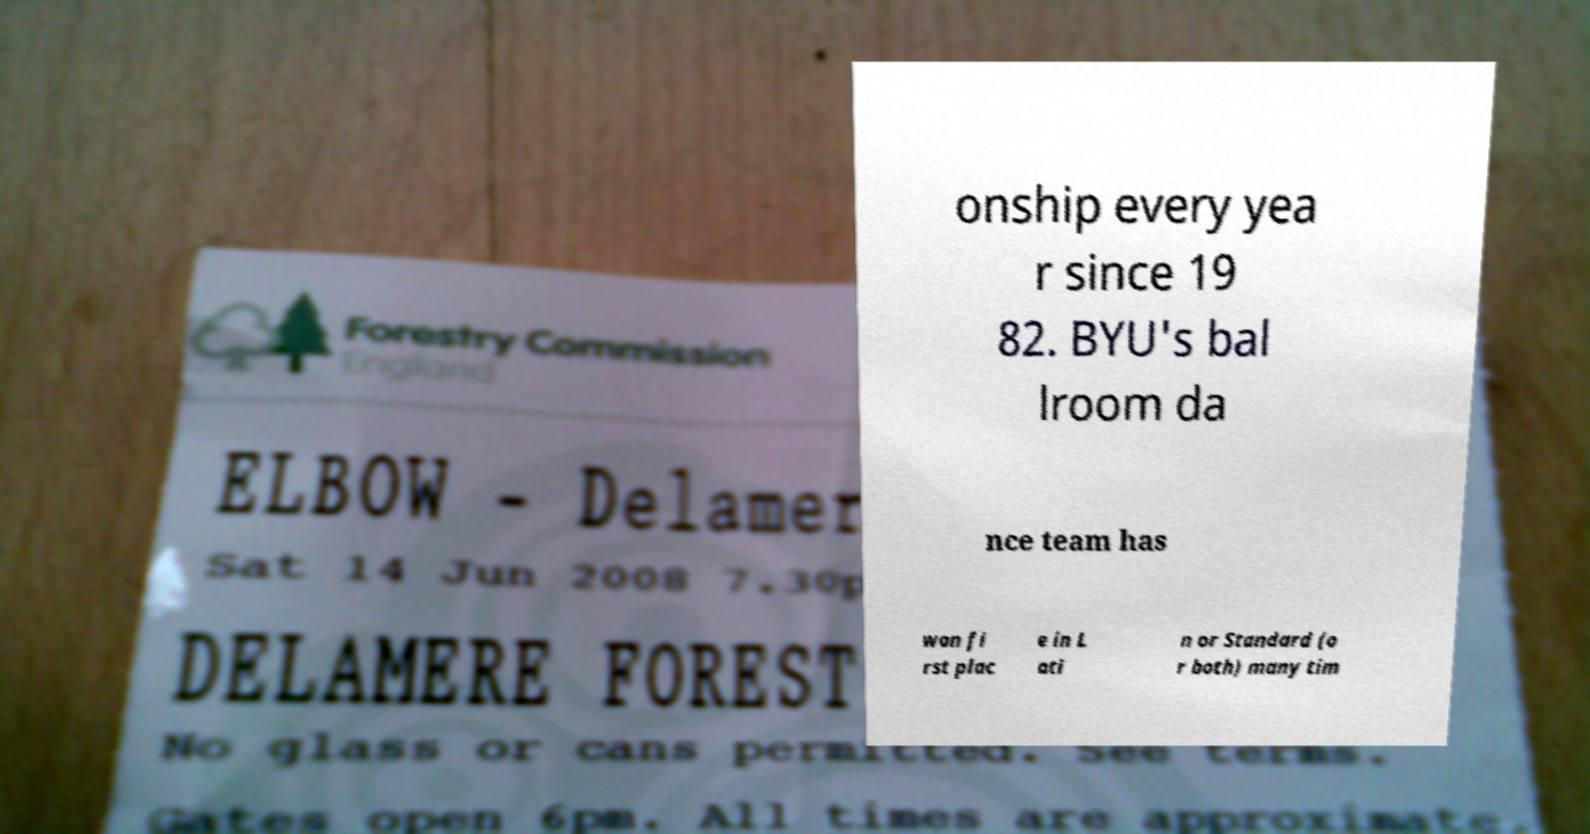Please read and relay the text visible in this image. What does it say? onship every yea r since 19 82. BYU's bal lroom da nce team has won fi rst plac e in L ati n or Standard (o r both) many tim 